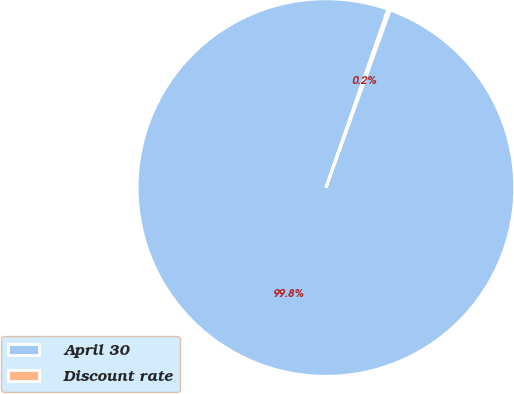Convert chart to OTSL. <chart><loc_0><loc_0><loc_500><loc_500><pie_chart><fcel>April 30<fcel>Discount rate<nl><fcel>99.8%<fcel>0.2%<nl></chart> 